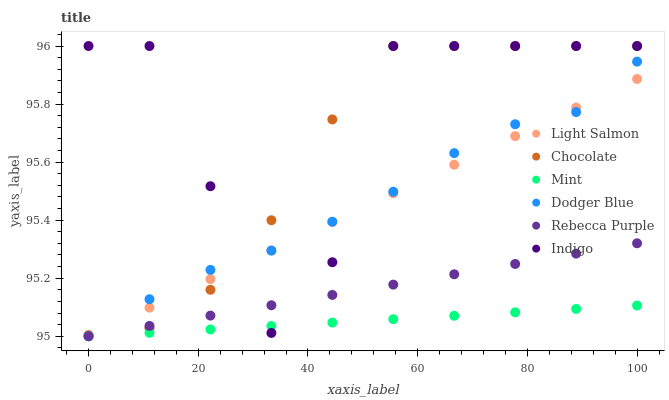Does Mint have the minimum area under the curve?
Answer yes or no. Yes. Does Indigo have the maximum area under the curve?
Answer yes or no. Yes. Does Chocolate have the minimum area under the curve?
Answer yes or no. No. Does Chocolate have the maximum area under the curve?
Answer yes or no. No. Is Rebecca Purple the smoothest?
Answer yes or no. Yes. Is Indigo the roughest?
Answer yes or no. Yes. Is Chocolate the smoothest?
Answer yes or no. No. Is Chocolate the roughest?
Answer yes or no. No. Does Light Salmon have the lowest value?
Answer yes or no. Yes. Does Chocolate have the lowest value?
Answer yes or no. No. Does Chocolate have the highest value?
Answer yes or no. Yes. Does Dodger Blue have the highest value?
Answer yes or no. No. Is Mint less than Chocolate?
Answer yes or no. Yes. Is Chocolate greater than Mint?
Answer yes or no. Yes. Does Dodger Blue intersect Indigo?
Answer yes or no. Yes. Is Dodger Blue less than Indigo?
Answer yes or no. No. Is Dodger Blue greater than Indigo?
Answer yes or no. No. Does Mint intersect Chocolate?
Answer yes or no. No. 